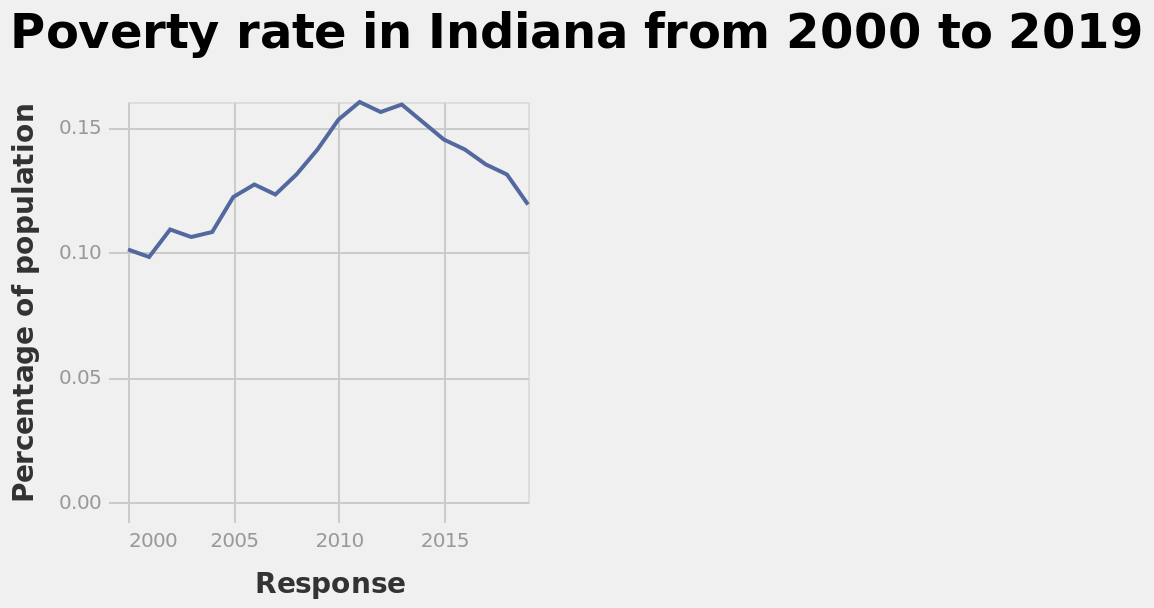<image>
Describe the following image in detail Poverty rate in Indiana from 2000 to 2019 is a line graph. The y-axis measures Percentage of population while the x-axis shows Response. What was the trend in the percentage of the population in poverty from 2000 to 2019? The percentage of the population in poverty increased steadily until 2011, took a small reduction in 2012 before rising again in 2013 before beginning to decrease steadily to 2019. What is being measured in the poverty rate graph for Indiana from 2000 to 2019? The graph is measuring the poverty rate percentage of the population in Indiana over the years 2000 to 2019. Has the percentage of the population in poverty returned to the levels seen in 2000? No, the percentage of the population in poverty has not returned to the levels seen in 2000. 